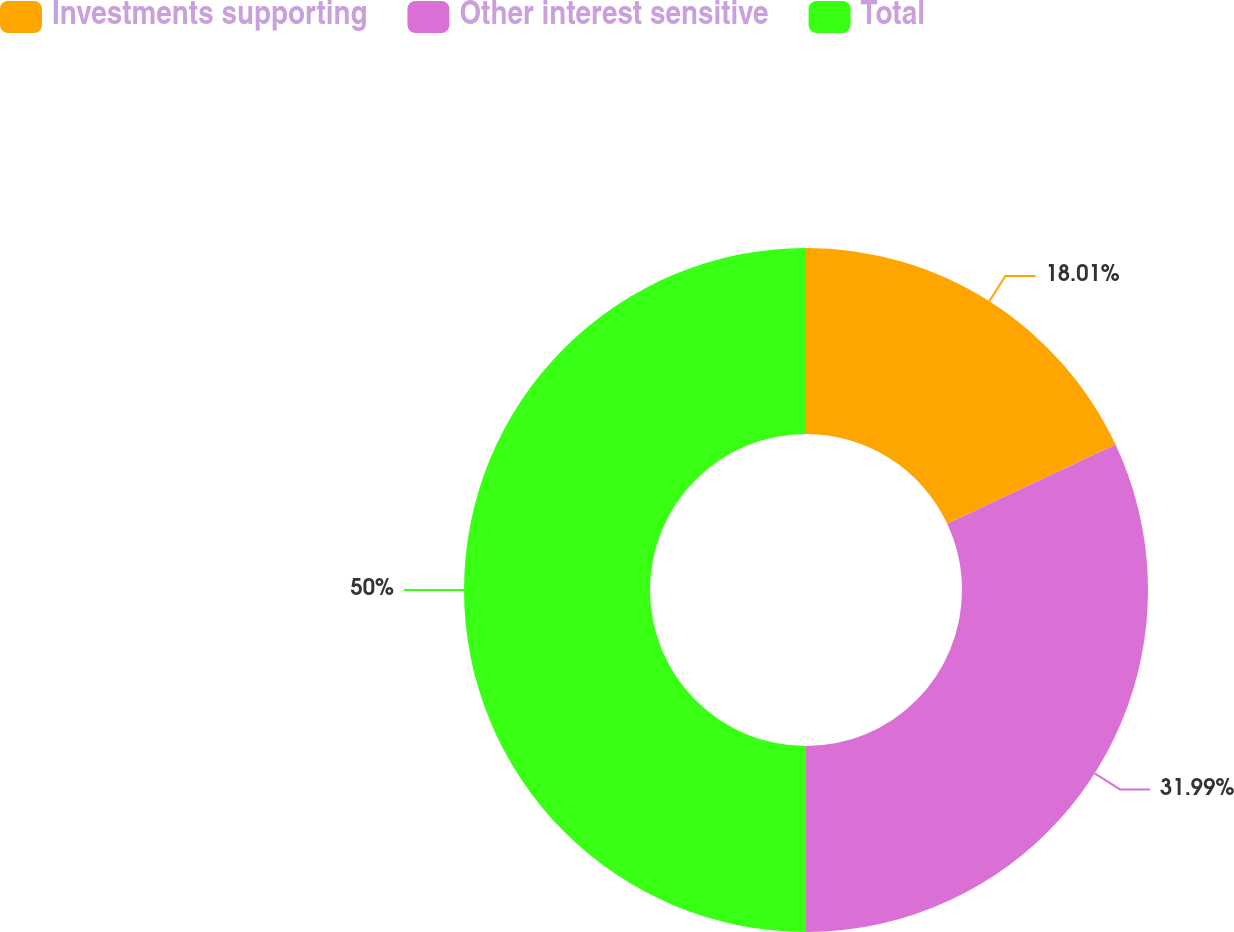Convert chart. <chart><loc_0><loc_0><loc_500><loc_500><pie_chart><fcel>Investments supporting<fcel>Other interest sensitive<fcel>Total<nl><fcel>18.01%<fcel>31.99%<fcel>50.0%<nl></chart> 